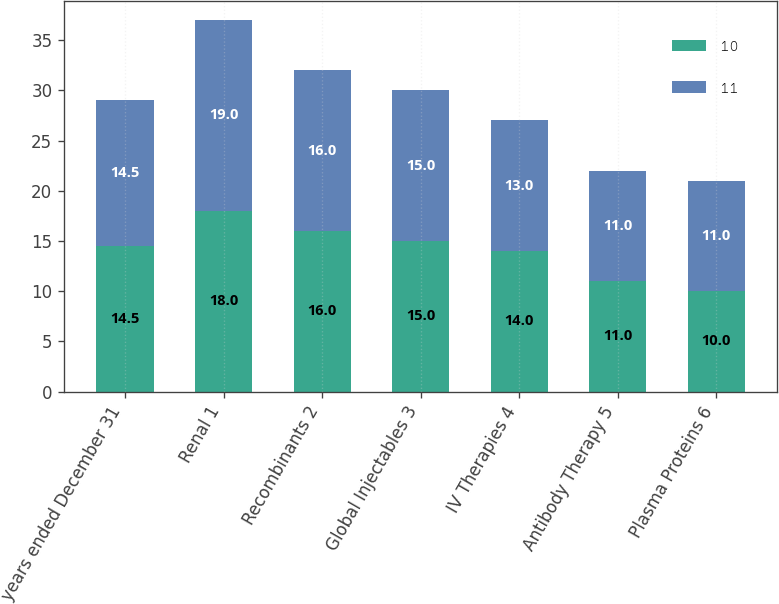<chart> <loc_0><loc_0><loc_500><loc_500><stacked_bar_chart><ecel><fcel>years ended December 31<fcel>Renal 1<fcel>Recombinants 2<fcel>Global Injectables 3<fcel>IV Therapies 4<fcel>Antibody Therapy 5<fcel>Plasma Proteins 6<nl><fcel>10<fcel>14.5<fcel>18<fcel>16<fcel>15<fcel>14<fcel>11<fcel>10<nl><fcel>11<fcel>14.5<fcel>19<fcel>16<fcel>15<fcel>13<fcel>11<fcel>11<nl></chart> 